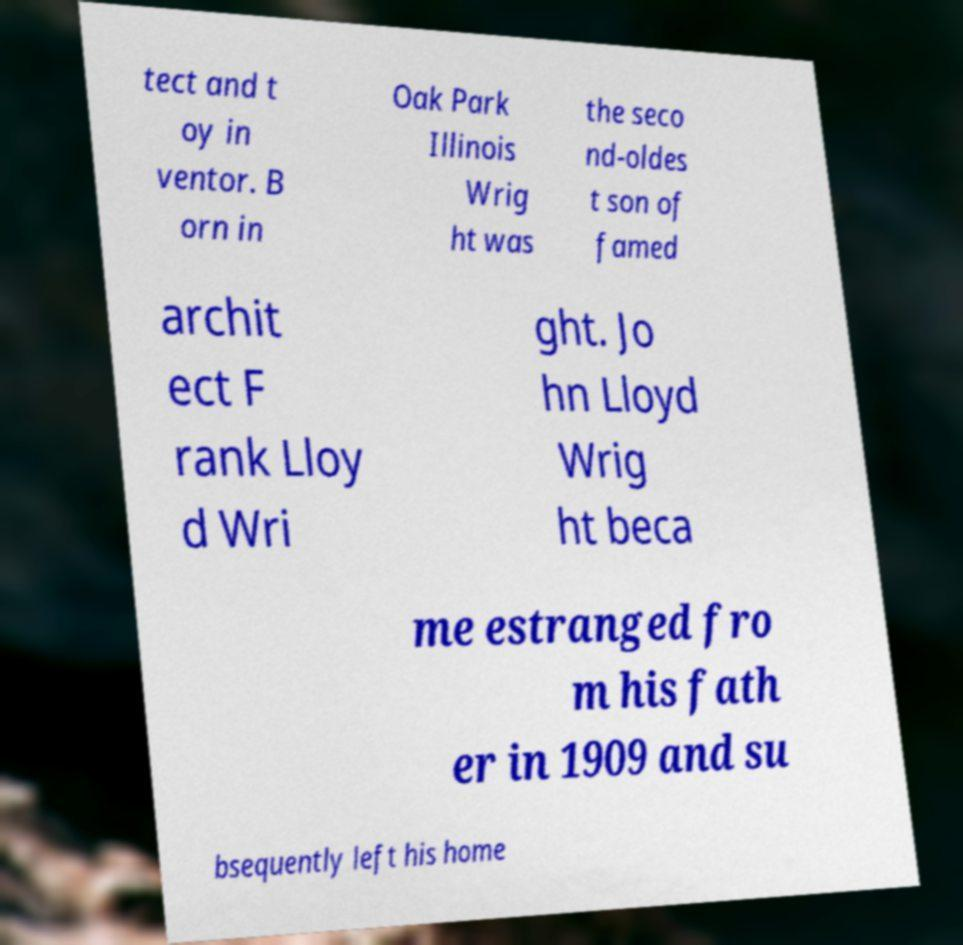Please identify and transcribe the text found in this image. tect and t oy in ventor. B orn in Oak Park Illinois Wrig ht was the seco nd-oldes t son of famed archit ect F rank Lloy d Wri ght. Jo hn Lloyd Wrig ht beca me estranged fro m his fath er in 1909 and su bsequently left his home 